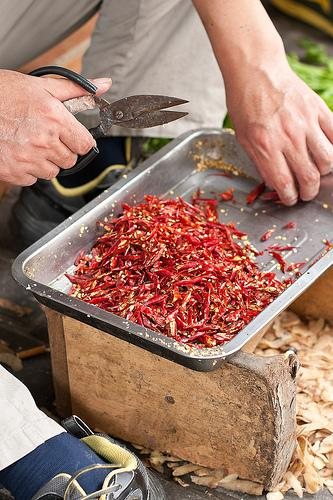Analyse the state of the wooden block and the shavings in the image. The wooden block appears to be made of natural wood with a screw or nail embedded in it. A pile of wood shavings surrounds the block. What objects can be found near the man's feet, and what is their state? Near the man's feet, there is an untied shoe, a pant leg, a foot in a shoe, a blue sock in a shoe, a pull tag on the back of the shoe, and a cigarette butt on the ground. Explain the man's interaction with the red chilies and his use of tools in the image. The man is using his left hand to scoop up chili peppers and his right hand to grasp pruning shears. He seems to be handling and processing the peppers. Describe the condition of the scissors and their features. The scissors are old and rusted, with a black handle and a central screw holding them together. What sentiment does the image evoke, considering the objects and actions depicted? The image evokes a sense of focused work and manual labor, as the man processes chilies using his hands and tools amidst a messy environment. Provide a brief overview of the central theme in the image. A man is working with red chilies on a silver tray, using scissors, and interacting with various objects in the scene, like a wooden block and a tin tray. Count the number of red chilies and wooden objects that are in the image. There's a pile of tiny red chilies (an exact number is not provided), and there are two wooden objects: a block and an overturned stool. What color are the man's socks, and what type of shoes is he wearing? The man is wearing navy blue socks and silver and black tennis shoes with a butter yellow interior. Is there any greenery in the image? If so, provide a brief description. Yes, there are green blurred out leaves, dried out leaves, and part of a green veggie in the image. What type of object is the man using to cut the red chilies, and what color is their handle? The man is using a rusty pair of scissors with a black handle to cut the red chilies. Where is the half-eaten sandwich placed near the pile of chilies? It must be the worker's lunch. This instruction is misleading because there is no half-eaten sandwich in the image. The interrogative statement encourages the reader to search for a nonexistent object, and the declarative portion creates a false narrative, suggesting the sandwich is the worker's lunch. Find the pink umbrella next to the wooden block, it's protecting the surrounding area from raindrops. There is no pink umbrella or any mention of a rainy environment in the given image. The interrogative statement prompts the reader to look for a nonexistent object, while the declarative sentence attempts to justify the presence of the umbrella. Can you spot the little frog hiding among the peppers? It might be camouflaged, so look closely! This instruction is misleading because there is no frog present in the image, and the focus is on peppers and the man working with them. The interrogative statement encourages the reader to search for a nonexistent object, while the declarative part of the sentence creates a false sense of possibility. Could you point out the small kitten playing with the wood shavings? It seems to be enjoying its time! This instruction is misleading because there is no kitten present in the image. The interrogative part asks the reader to search for an object that doesn't exist in the given context, and the declarative statement falsely suggests that the kitten is interacting with other elements of the image. Can you see the blue butterfly perched on the hand holding the shears? It's beautiful, isn't it? This instruction is misleading because there is no butterfly present in the image, specifically on the hand holding the shears. The interrogative statement encourages the reader to find a nonexistent object, and the declarative sentence attempts to create a sense of awe for the imaginary butterfly. Is there a hidden treasure chest under the overturned wooden stool? Some say it contains a fortune! There is no treasure chest beneath the wooden stool in the image, nor any mention of one. The interrogative statement asks the reader to search for something that doesn't exist, while the declarative part creates a false sense of mystery and excitement. 